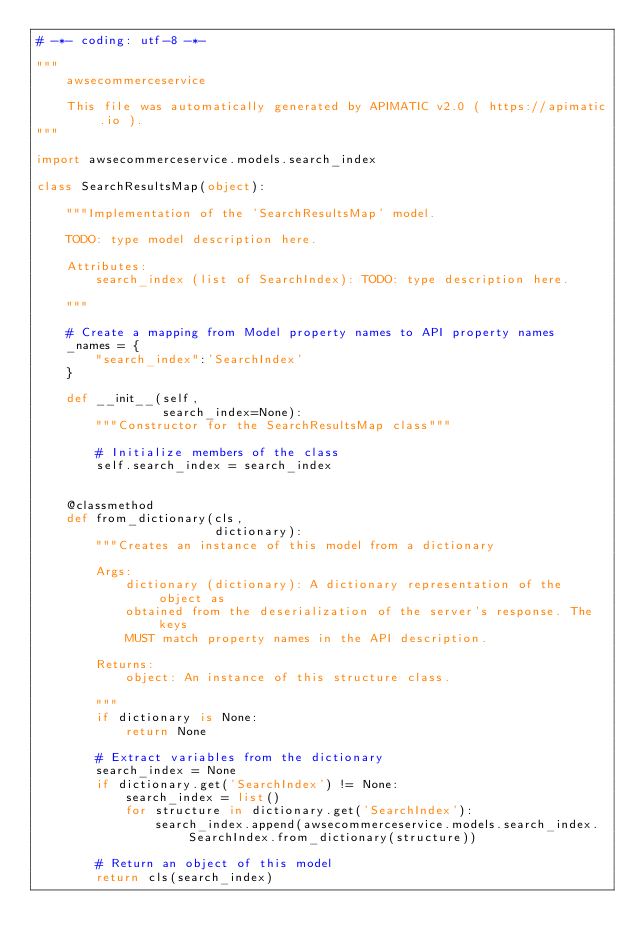<code> <loc_0><loc_0><loc_500><loc_500><_Python_># -*- coding: utf-8 -*-

"""
    awsecommerceservice

    This file was automatically generated by APIMATIC v2.0 ( https://apimatic.io ).
"""

import awsecommerceservice.models.search_index

class SearchResultsMap(object):

    """Implementation of the 'SearchResultsMap' model.

    TODO: type model description here.

    Attributes:
        search_index (list of SearchIndex): TODO: type description here.

    """

    # Create a mapping from Model property names to API property names
    _names = {
        "search_index":'SearchIndex'
    }

    def __init__(self,
                 search_index=None):
        """Constructor for the SearchResultsMap class"""

        # Initialize members of the class
        self.search_index = search_index


    @classmethod
    def from_dictionary(cls,
                        dictionary):
        """Creates an instance of this model from a dictionary

        Args:
            dictionary (dictionary): A dictionary representation of the object as
            obtained from the deserialization of the server's response. The keys
            MUST match property names in the API description.

        Returns:
            object: An instance of this structure class.

        """
        if dictionary is None:
            return None

        # Extract variables from the dictionary
        search_index = None
        if dictionary.get('SearchIndex') != None:
            search_index = list()
            for structure in dictionary.get('SearchIndex'):
                search_index.append(awsecommerceservice.models.search_index.SearchIndex.from_dictionary(structure))

        # Return an object of this model
        return cls(search_index)


</code> 